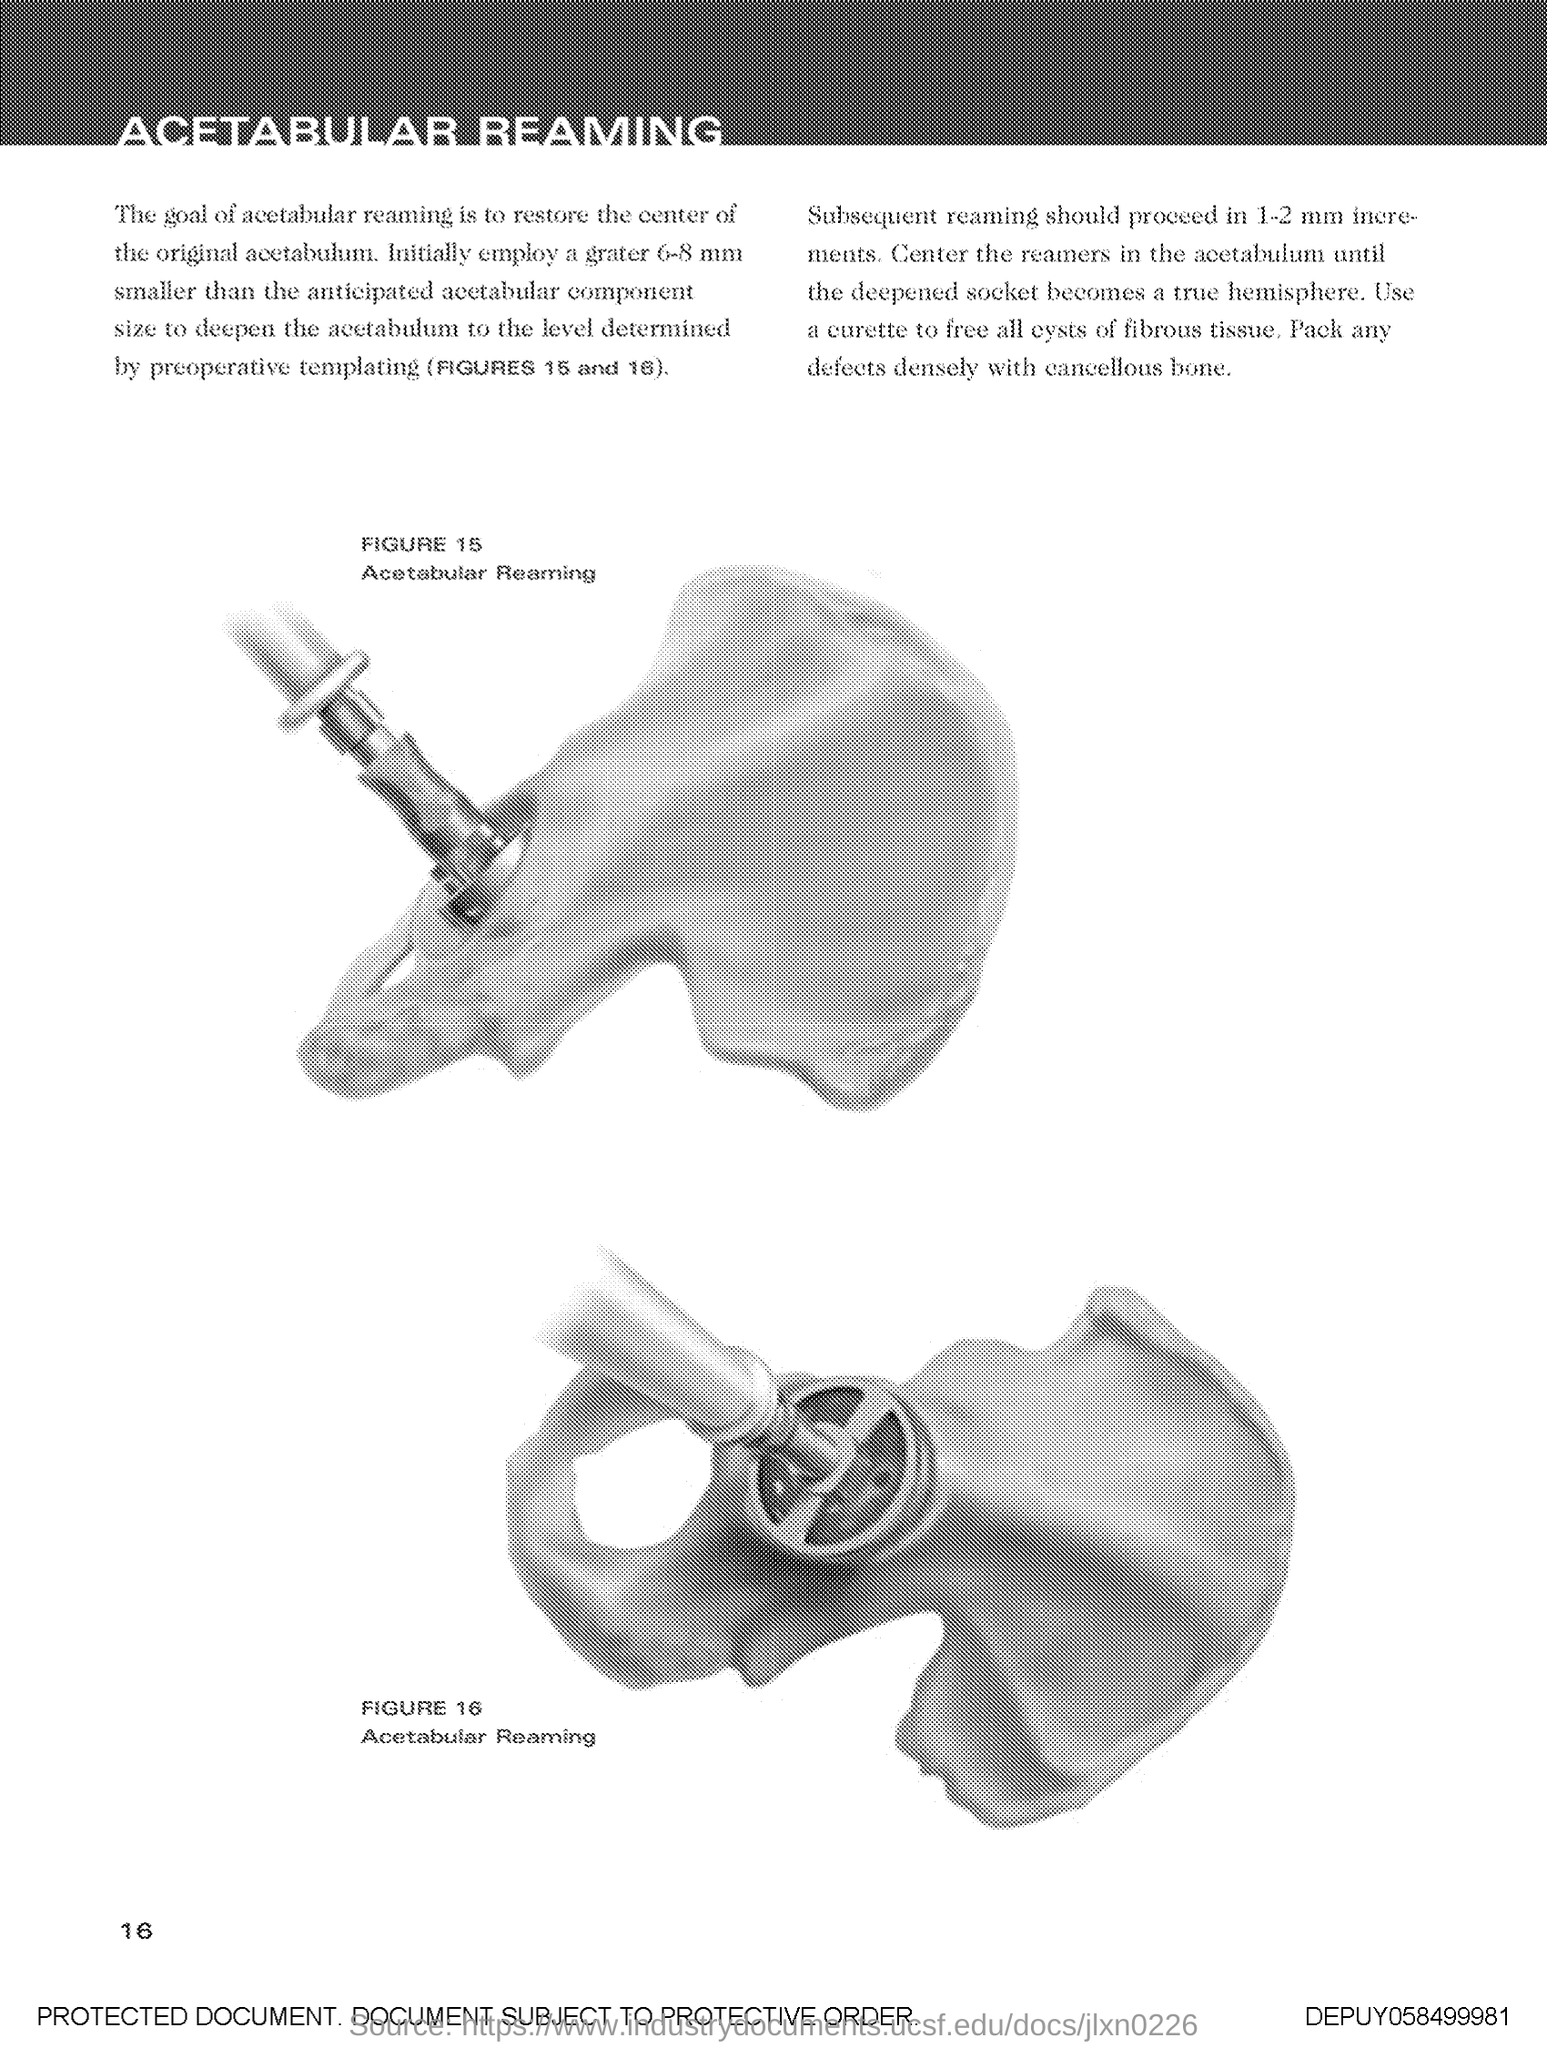Draw attention to some important aspects in this diagram. The number at the bottom-left side of the page is 16. 